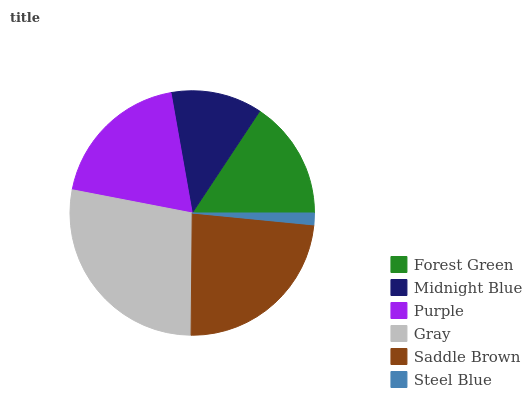Is Steel Blue the minimum?
Answer yes or no. Yes. Is Gray the maximum?
Answer yes or no. Yes. Is Midnight Blue the minimum?
Answer yes or no. No. Is Midnight Blue the maximum?
Answer yes or no. No. Is Forest Green greater than Midnight Blue?
Answer yes or no. Yes. Is Midnight Blue less than Forest Green?
Answer yes or no. Yes. Is Midnight Blue greater than Forest Green?
Answer yes or no. No. Is Forest Green less than Midnight Blue?
Answer yes or no. No. Is Purple the high median?
Answer yes or no. Yes. Is Forest Green the low median?
Answer yes or no. Yes. Is Midnight Blue the high median?
Answer yes or no. No. Is Steel Blue the low median?
Answer yes or no. No. 